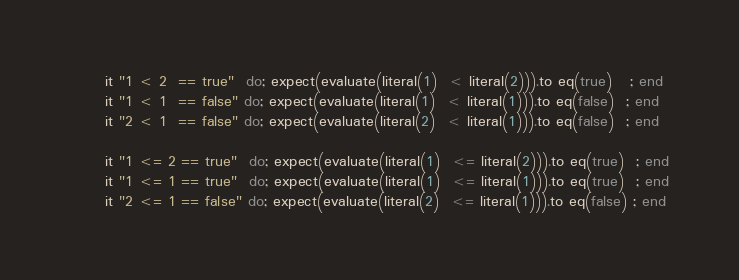Convert code to text. <code><loc_0><loc_0><loc_500><loc_500><_Ruby_>      it "1 < 2  == true"  do; expect(evaluate(literal(1)  < literal(2))).to eq(true)   ; end
      it "1 < 1  == false" do; expect(evaluate(literal(1)  < literal(1))).to eq(false)  ; end
      it "2 < 1  == false" do; expect(evaluate(literal(2)  < literal(1))).to eq(false)  ; end

      it "1 <= 2 == true"  do; expect(evaluate(literal(1)  <= literal(2))).to eq(true)  ; end
      it "1 <= 1 == true"  do; expect(evaluate(literal(1)  <= literal(1))).to eq(true)  ; end
      it "2 <= 1 == false" do; expect(evaluate(literal(2)  <= literal(1))).to eq(false) ; end
</code> 